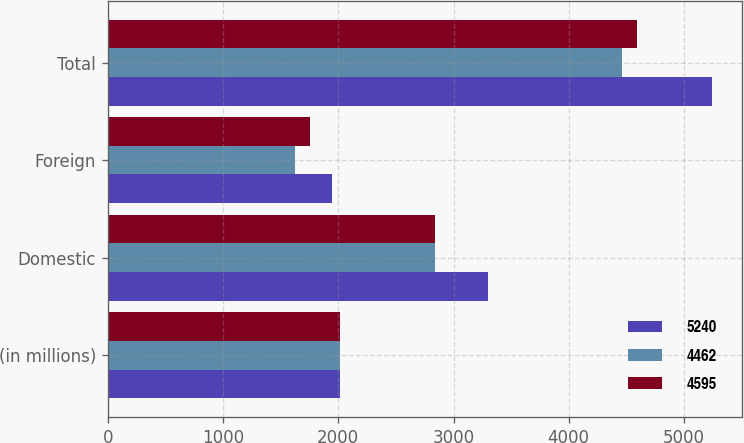<chart> <loc_0><loc_0><loc_500><loc_500><stacked_bar_chart><ecel><fcel>(in millions)<fcel>Domestic<fcel>Foreign<fcel>Total<nl><fcel>5240<fcel>2017<fcel>3298<fcel>1942<fcel>5240<nl><fcel>4462<fcel>2016<fcel>2837<fcel>1625<fcel>4462<nl><fcel>4595<fcel>2015<fcel>2840<fcel>1755<fcel>4595<nl></chart> 